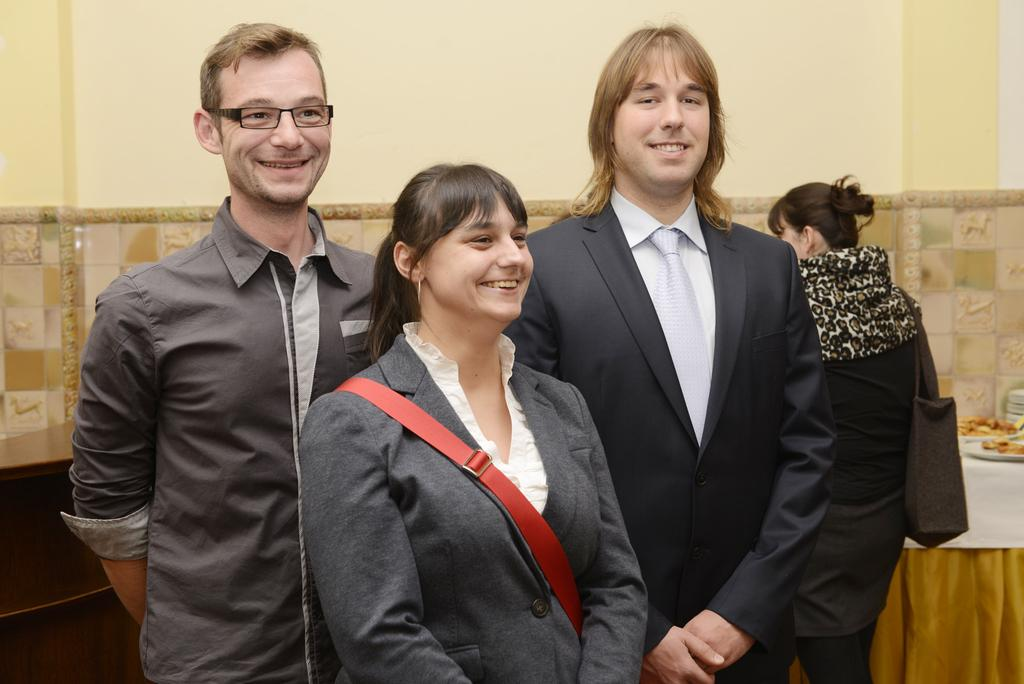What are the people in the image doing? The persons standing on the ground are likely engaged in some activity or gathering. What can be seen in the background of the image? There are serving plates with food and a wall visible in the background. What type of material is present in the background? Cloth is visible in the background. What type of precipitation is falling from the sky in the image? There is no precipitation visible in the image, so it cannot be determined if any type of precipitation is falling. 